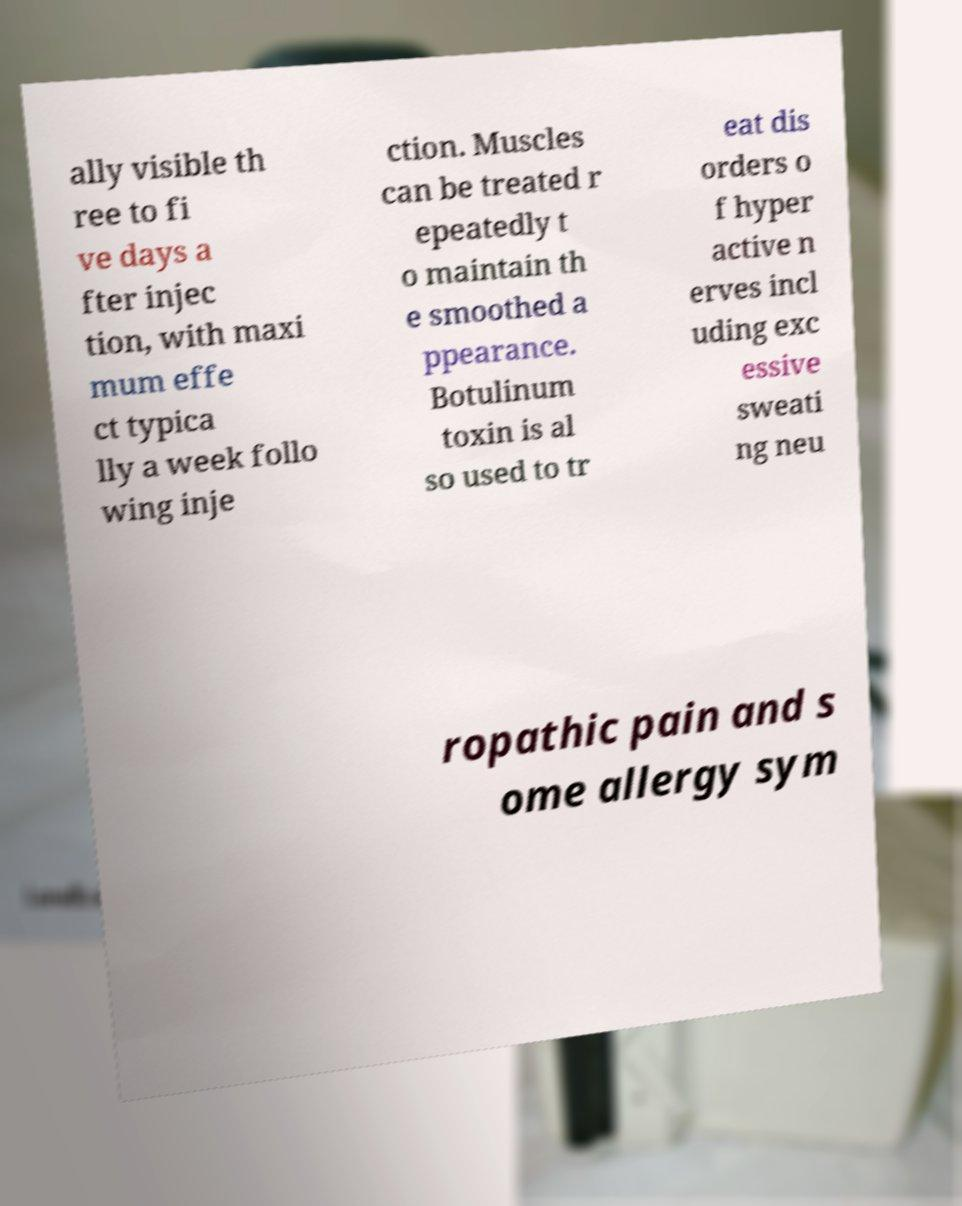I need the written content from this picture converted into text. Can you do that? ally visible th ree to fi ve days a fter injec tion, with maxi mum effe ct typica lly a week follo wing inje ction. Muscles can be treated r epeatedly t o maintain th e smoothed a ppearance. Botulinum toxin is al so used to tr eat dis orders o f hyper active n erves incl uding exc essive sweati ng neu ropathic pain and s ome allergy sym 